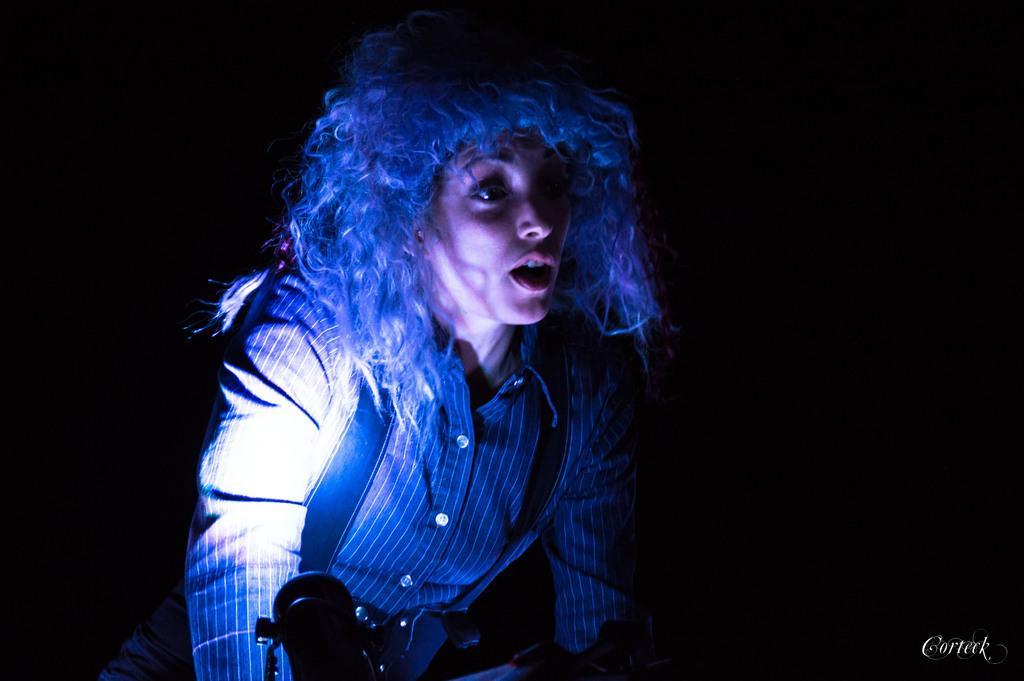Could you give a brief overview of what you see in this image? In this image I can see a woman facing towards the right side and speaking. The background is in black color. In the bottom right there is some text. 